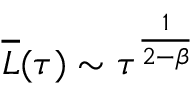Convert formula to latex. <formula><loc_0><loc_0><loc_500><loc_500>\overline { L } ( \tau ) \sim \tau ^ { \frac { 1 } { 2 - \beta } }</formula> 